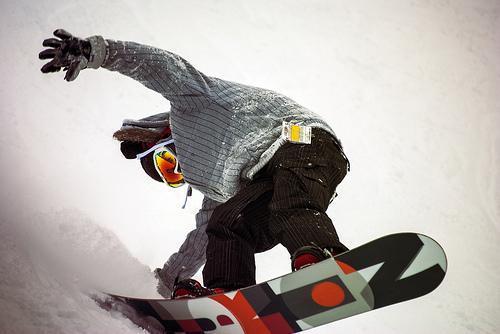How many people are in the picture?
Give a very brief answer. 1. 